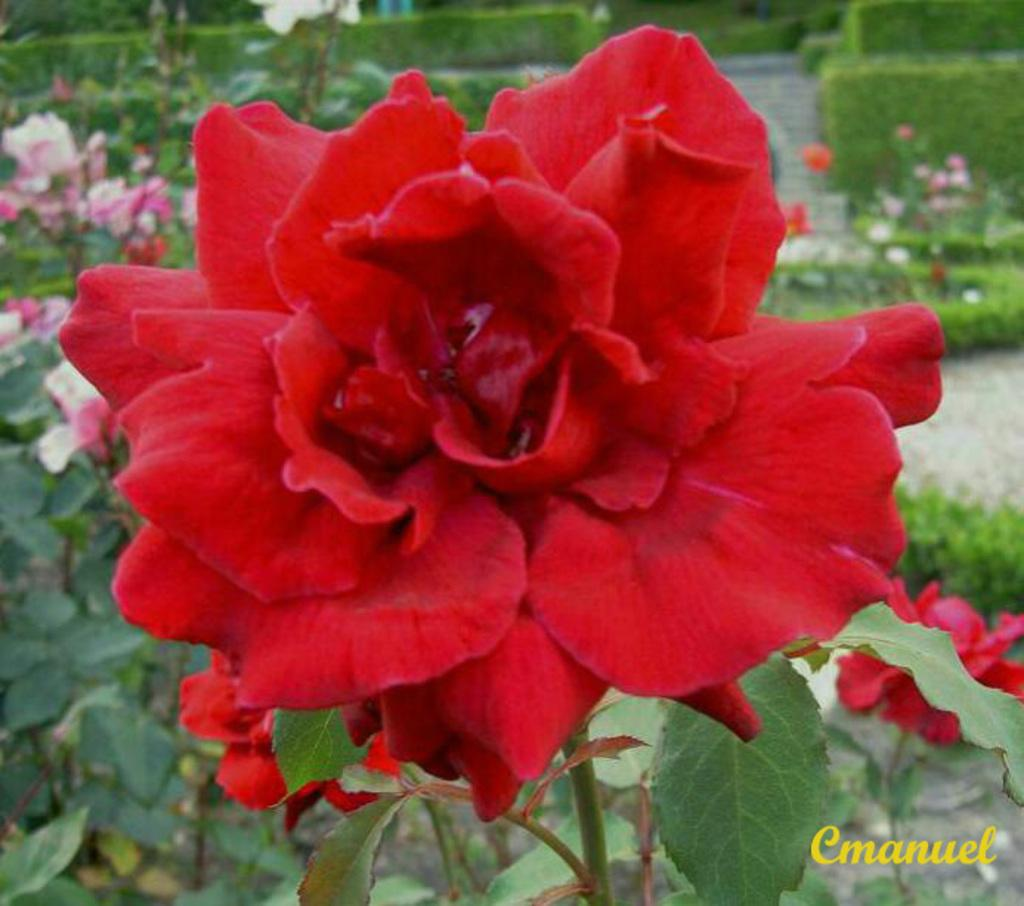What type of living organisms can be seen in the image? Plants can be seen in the image. What specific features do the plants have? The plants have flowers, which are red and pink in color. What can be seen in the background of the image? There are bushes and a path visible in the background. Is there any text or logo present in the image? Yes, there is a watermark in the image. What type of button can be seen in the image? There is no button present in the image; it features plants with flowers and a background with bushes and a path. 